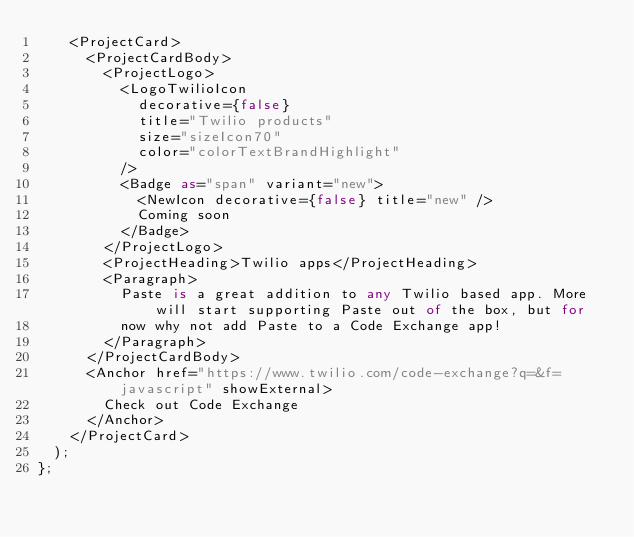<code> <loc_0><loc_0><loc_500><loc_500><_TypeScript_>    <ProjectCard>
      <ProjectCardBody>
        <ProjectLogo>
          <LogoTwilioIcon
            decorative={false}
            title="Twilio products"
            size="sizeIcon70"
            color="colorTextBrandHighlight"
          />
          <Badge as="span" variant="new">
            <NewIcon decorative={false} title="new" />
            Coming soon
          </Badge>
        </ProjectLogo>
        <ProjectHeading>Twilio apps</ProjectHeading>
        <Paragraph>
          Paste is a great addition to any Twilio based app. More will start supporting Paste out of the box, but for
          now why not add Paste to a Code Exchange app!
        </Paragraph>
      </ProjectCardBody>
      <Anchor href="https://www.twilio.com/code-exchange?q=&f=javascript" showExternal>
        Check out Code Exchange
      </Anchor>
    </ProjectCard>
  );
};
</code> 